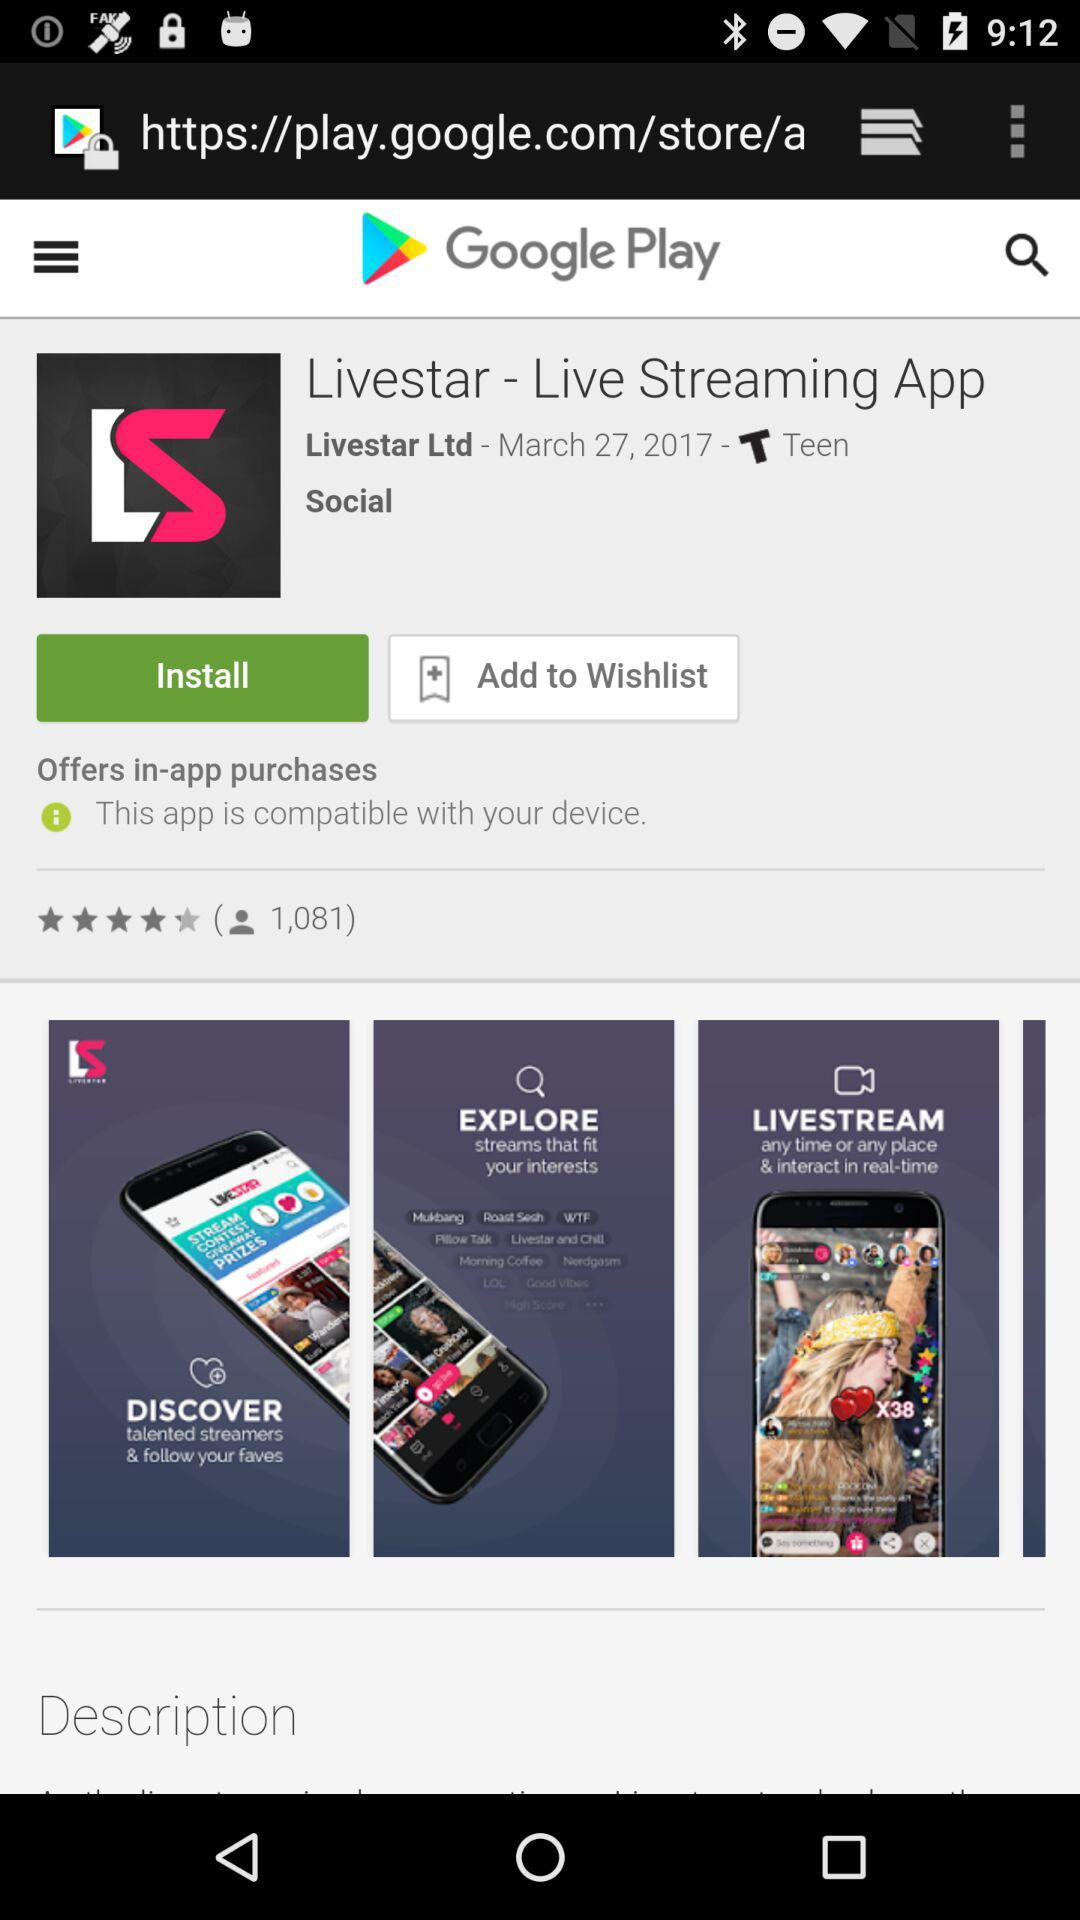What is the application name? The application name is "Livestar - Live Streaming App". 